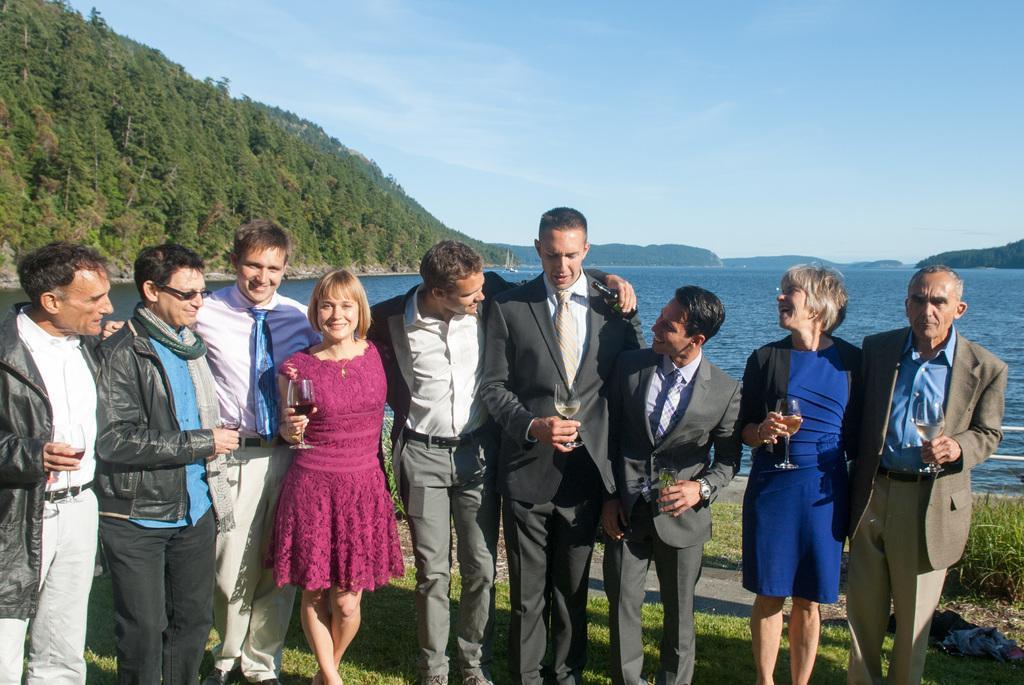Can you describe this image briefly? In front of the image there are people holding the glasses. At the bottom of the image there are some clothes on the grass. In the background of the image there is a ship in the water. There are trees, mountains. At the top of the image there is sky. 